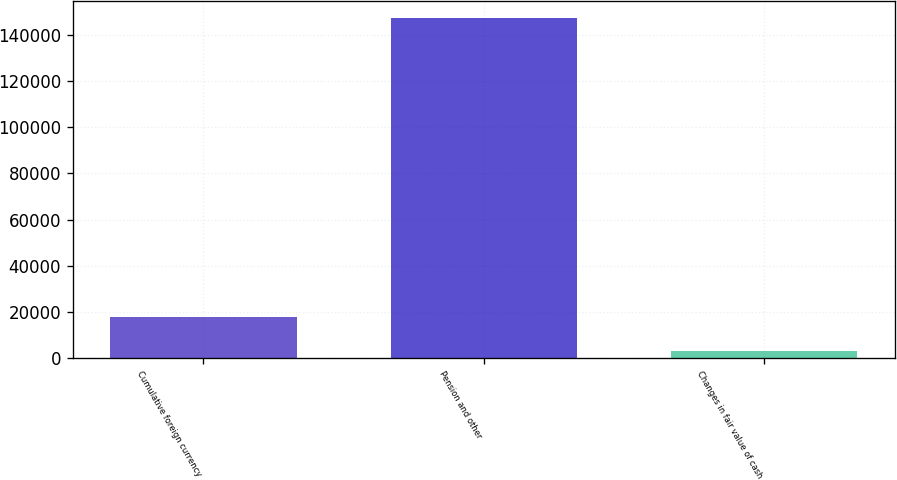Convert chart. <chart><loc_0><loc_0><loc_500><loc_500><bar_chart><fcel>Cumulative foreign currency<fcel>Pension and other<fcel>Changes in fair value of cash<nl><fcel>17594.7<fcel>147237<fcel>3190<nl></chart> 